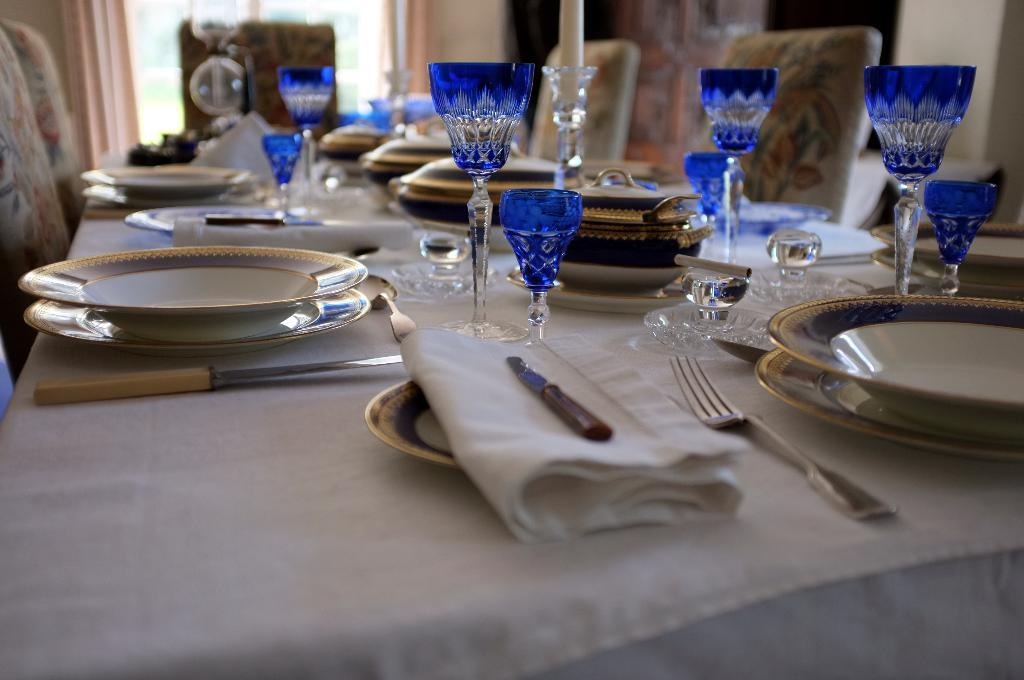What type of furniture is in the image? The dining table is present in the image. What color are the glasses on the table? There are blue glasses on the table. What other tableware is visible on the table? Plates, forks, and knives are present on the table. How many chairs are around the table? A group of chairs is around the table. How much money is on the table in the image? There is no money present on the table in the image. Is there a dock visible in the image? There is no dock present in the image. 